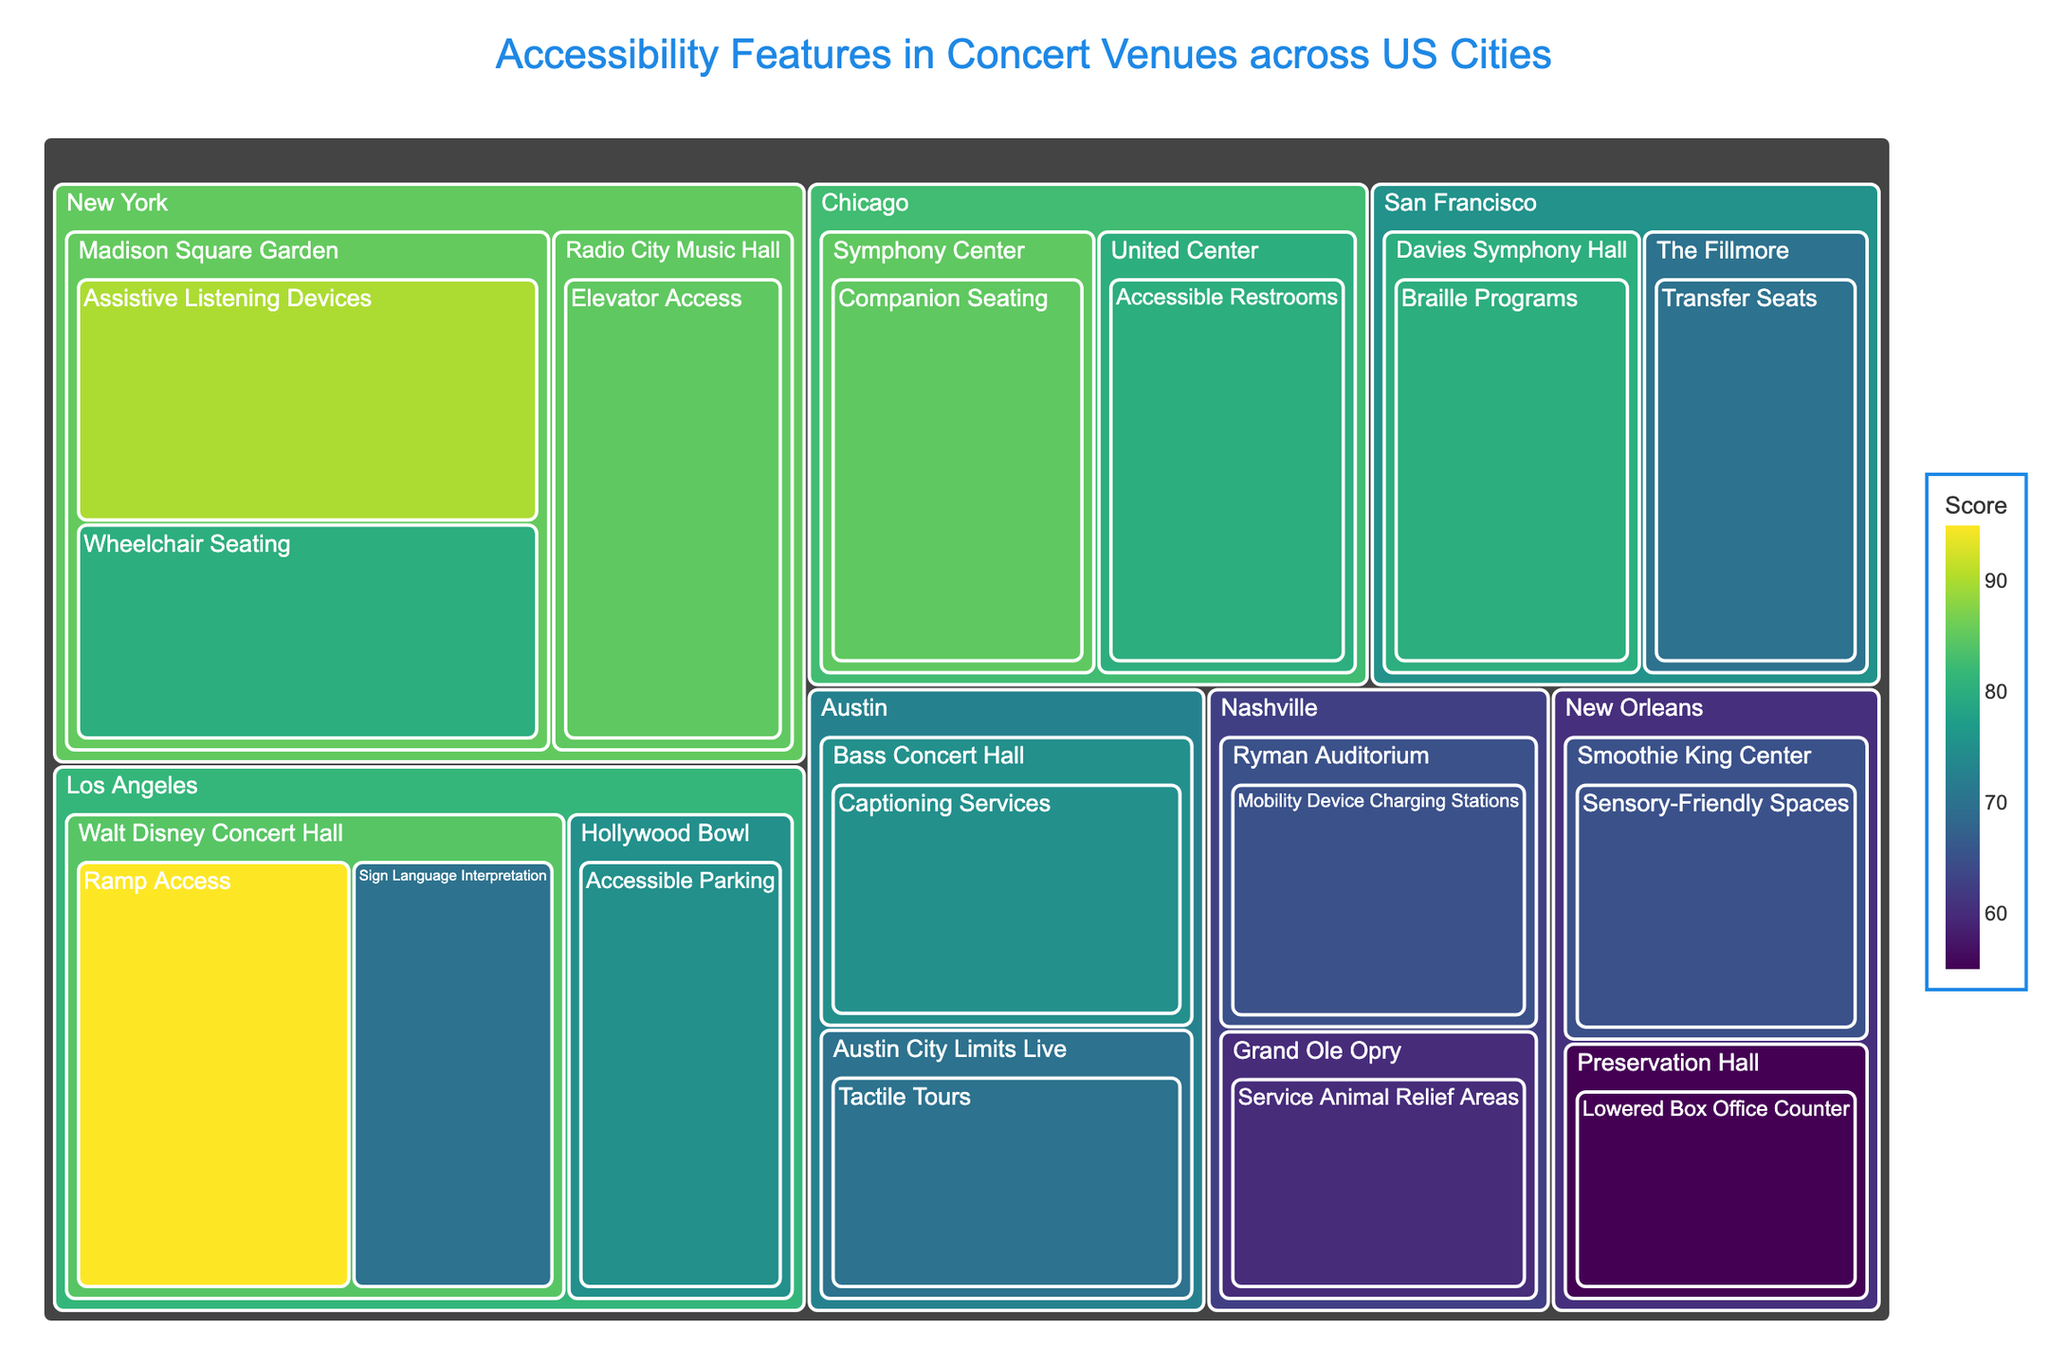What city has the highest average score for accessibility features in its venues? Calculate the average score for each city by adding the scores of all features in each city and dividing by the number of features. Compare the averages.
Answer: New York How many accessibility features are listed for Austin? Count the unique accessibility features specifically listed under Austin.
Answer: 2 Which city has the lowest score for any feature, and what is the feature? Identify the lowest numerical score and its corresponding city and feature.
Answer: New Orleans, Lowered Box Office Counter Which venue in Los Angeles has a higher score for Ramp Access compared to Accessible Parking? Compare the scores for Ramp Access and Accessible Parking within the venues in Los Angeles.
Answer: Walt Disney Concert Hall What is the combined score of all accessibility features in Nashvill e? Add up all the scores of the accessibility features listed under Nashville.
Answer: 125 Compare the scores for Wheelchair Seating and Assistive Listening Devices at Madison Square Garden. Which one is higher? Look at the score for each feature at Madison Square Garden and determine which one is greater.
Answer: Assistive Listening Devices Which city has venues listed with at least three distinct accessibility features? Count the number of unique accessibility features for each venue in each city and identify the cities with at least three features.
Answer: New York Identify all features with a score above 80 in Chicago. List the features in Chicago and check which ones have scores above 80.
Answer: Companion Seating For the venue Davies Symphony Hall in San Francisco, what is the accessibility feature listed? Look for the accessibility feature associated with Davies Symphony Hall in the data.
Answer: Braille Programs What is the overall highest score mentioned in the figure, and which feature and venue does it belong to? Locate the highest score in the data and identify the corresponding feature and venue.
Answer: Ramp Access, Walt Disney Concert Hall 